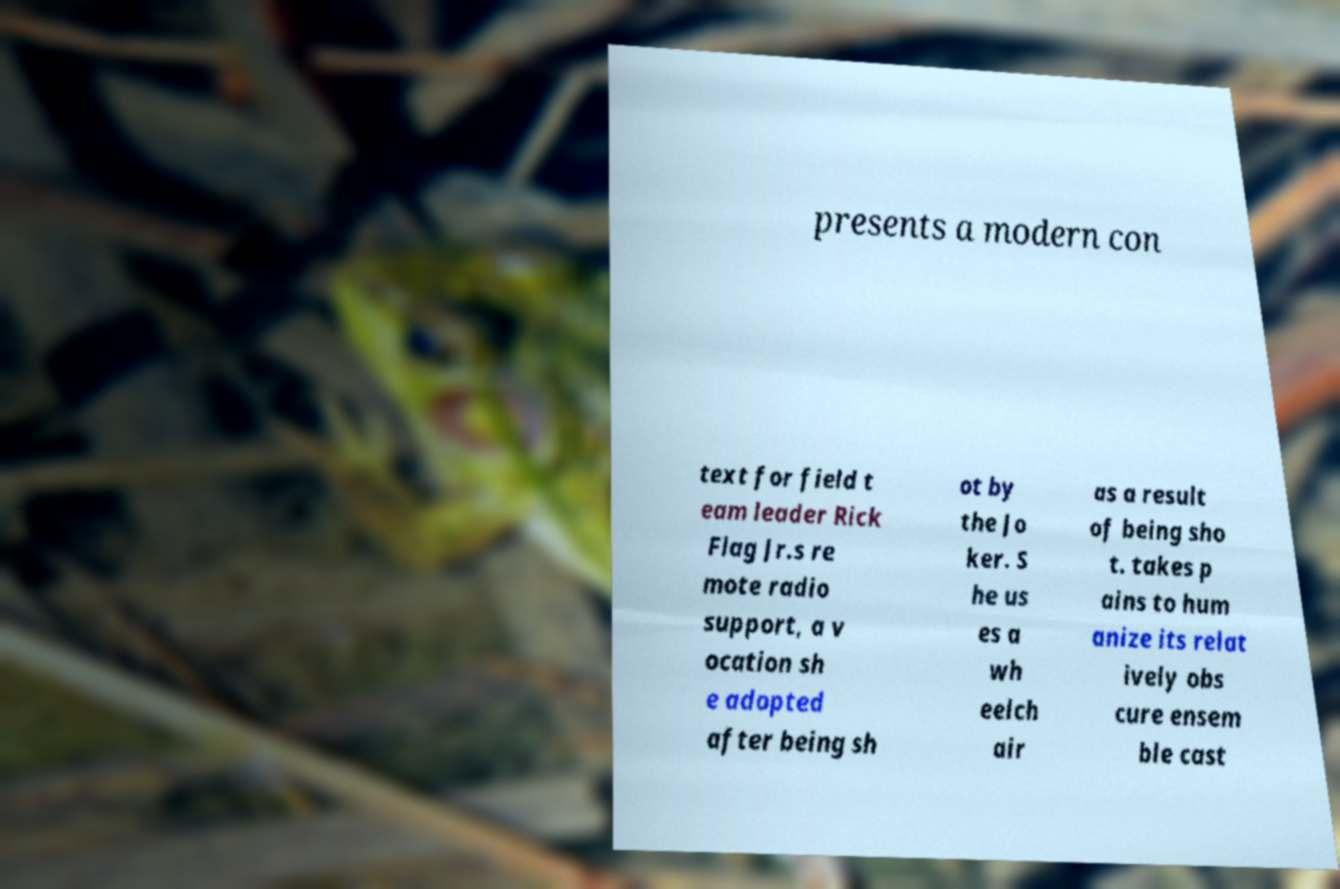For documentation purposes, I need the text within this image transcribed. Could you provide that? presents a modern con text for field t eam leader Rick Flag Jr.s re mote radio support, a v ocation sh e adopted after being sh ot by the Jo ker. S he us es a wh eelch air as a result of being sho t. takes p ains to hum anize its relat ively obs cure ensem ble cast 